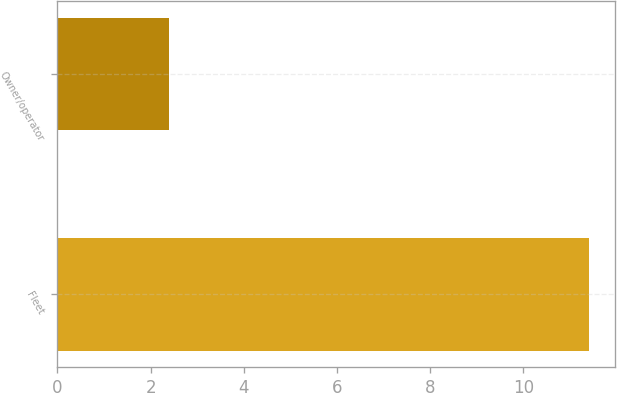Convert chart. <chart><loc_0><loc_0><loc_500><loc_500><bar_chart><fcel>Fleet<fcel>Owner/operator<nl><fcel>11.4<fcel>2.4<nl></chart> 